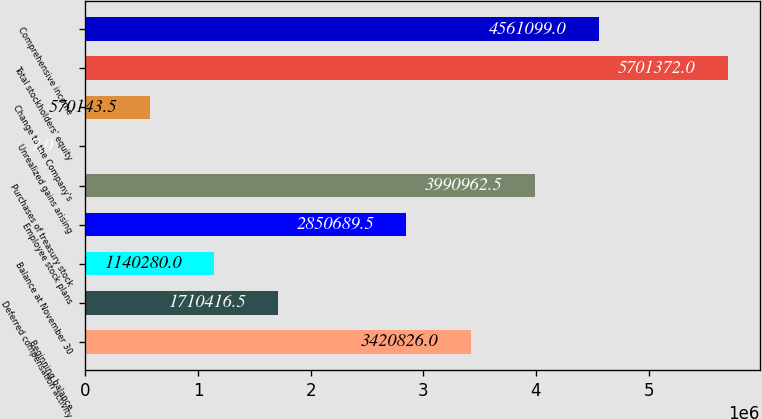<chart> <loc_0><loc_0><loc_500><loc_500><bar_chart><fcel>Beginning balance<fcel>Deferred compensation activity<fcel>Balance at November 30<fcel>Employee stock plans<fcel>Purchases of treasury stock<fcel>Unrealized gains arising<fcel>Change to the Company's<fcel>Total stockholders' equity<fcel>Comprehensive income<nl><fcel>3.42083e+06<fcel>1.71042e+06<fcel>1.14028e+06<fcel>2.85069e+06<fcel>3.99096e+06<fcel>7<fcel>570144<fcel>5.70137e+06<fcel>4.5611e+06<nl></chart> 